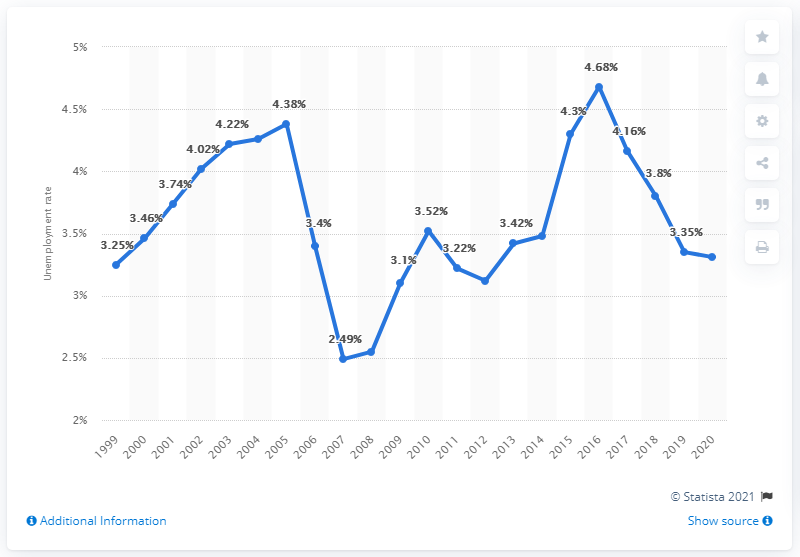Highlight a few significant elements in this photo. According to recent data, the unemployment rate in Norway during the year 2020 was 3.31%. 